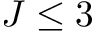Convert formula to latex. <formula><loc_0><loc_0><loc_500><loc_500>J \leq 3</formula> 